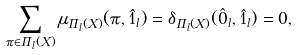<formula> <loc_0><loc_0><loc_500><loc_500>\sum _ { \pi \in \Pi _ { l } ( X ) } \mu _ { \Pi _ { l } ( X ) } ( \pi , \hat { 1 } _ { l } ) & = \delta _ { \Pi _ { l } ( X ) } ( \hat { 0 } _ { l } , \hat { 1 } _ { l } ) = 0 ,</formula> 